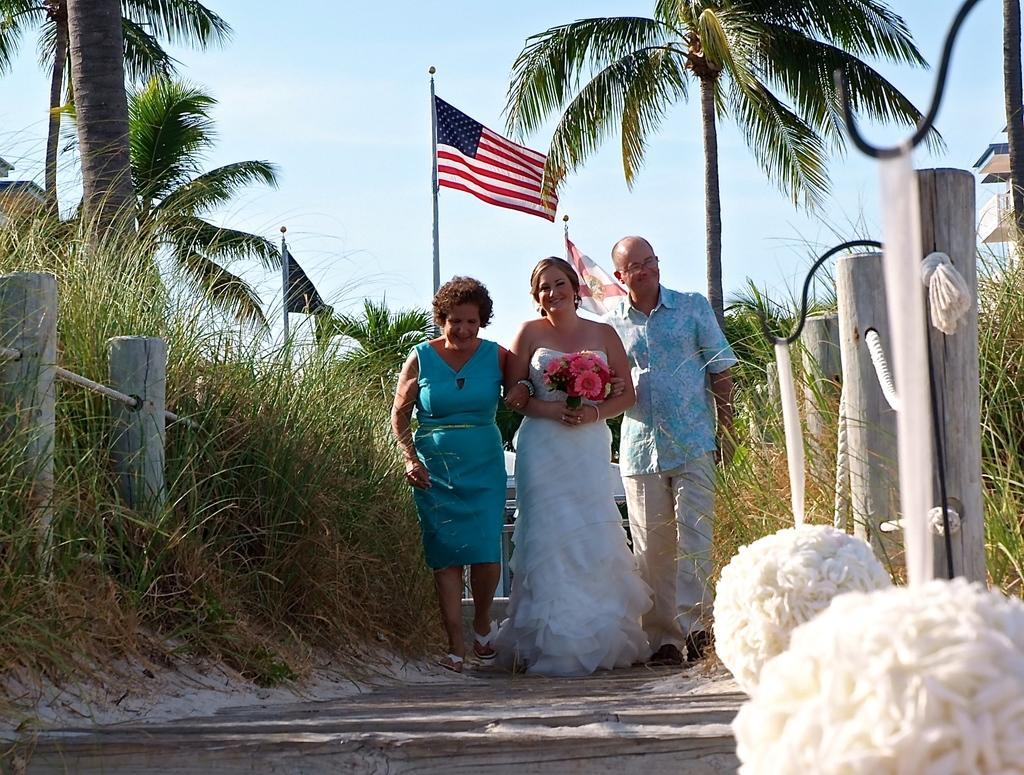In one or two sentences, can you explain what this image depicts? In this image we can see three persons are standing, and smiling, there a woman is holding a flower bokeh in the hand, at the back there are trees, there is a fencing, there are flags, there is a sky. 